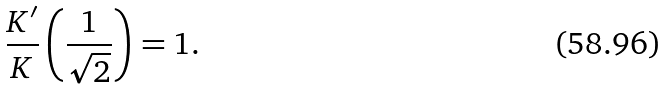Convert formula to latex. <formula><loc_0><loc_0><loc_500><loc_500>\frac { K ^ { \prime } } { K } \left ( \frac { 1 } { \sqrt { 2 } } \right ) = 1 .</formula> 